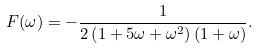Convert formula to latex. <formula><loc_0><loc_0><loc_500><loc_500>F ( \omega ) = - \frac { 1 } { 2 \left ( 1 + 5 \omega + \omega ^ { 2 } \right ) \left ( 1 + \omega \right ) } .</formula> 